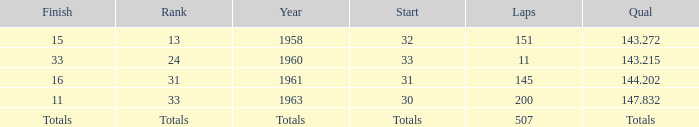Parse the full table. {'header': ['Finish', 'Rank', 'Year', 'Start', 'Laps', 'Qual'], 'rows': [['15', '13', '1958', '32', '151', '143.272'], ['33', '24', '1960', '33', '11', '143.215'], ['16', '31', '1961', '31', '145', '144.202'], ['11', '33', '1963', '30', '200', '147.832'], ['Totals', 'Totals', 'Totals', 'Totals', '507', 'Totals']]} What year did the rank of 31 happen in? 1961.0. 